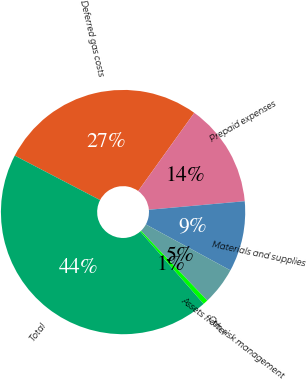Convert chart to OTSL. <chart><loc_0><loc_0><loc_500><loc_500><pie_chart><fcel>Deferred gas costs<fcel>Prepaid expenses<fcel>Materials and supplies<fcel>Assets from risk management<fcel>Other<fcel>Total<nl><fcel>27.26%<fcel>13.68%<fcel>9.33%<fcel>4.98%<fcel>0.64%<fcel>44.11%<nl></chart> 